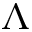Convert formula to latex. <formula><loc_0><loc_0><loc_500><loc_500>\Lambda</formula> 